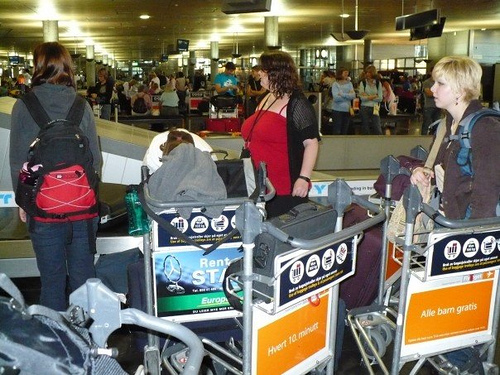Read all the text in this image. Alle barri Y Europe Rent 